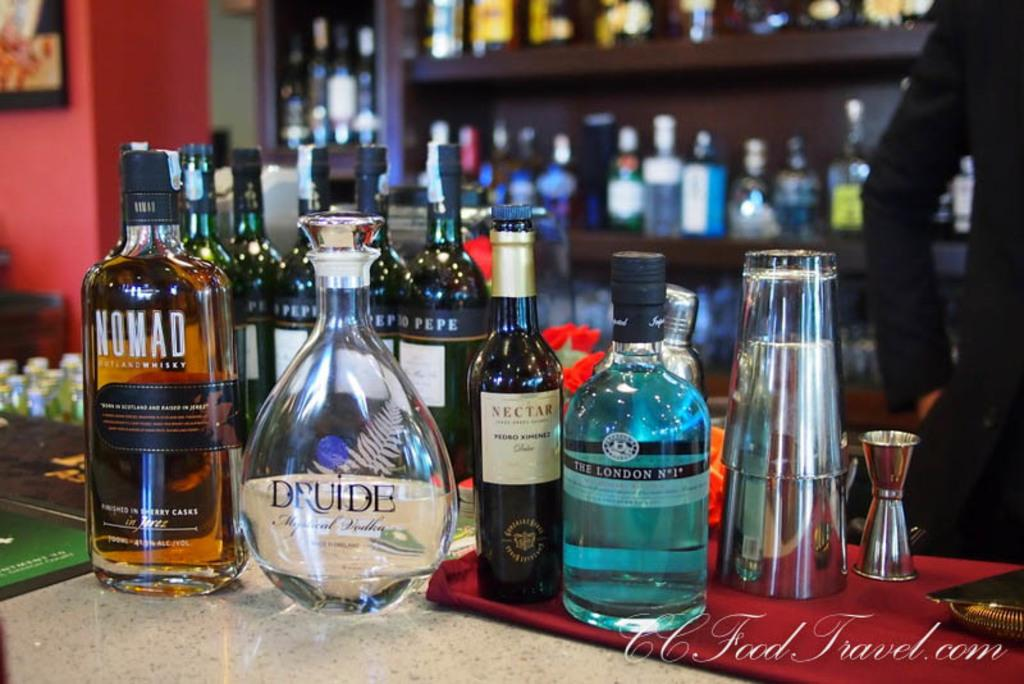What is the person in the image doing? The person is standing behind a table. What objects are on the table? There are glasses and bottles with different labels on the table. Where are additional bottles located in the image? There are bottles in a cupboard at the back. What type of support does the person's arm need in the image? There is no indication in the image that the person's arm needs any support. 